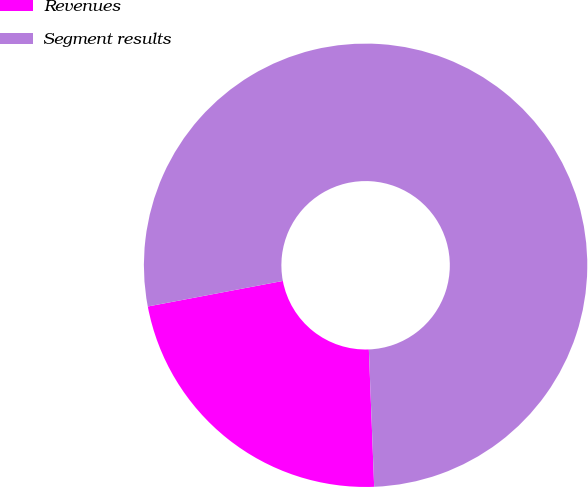Convert chart to OTSL. <chart><loc_0><loc_0><loc_500><loc_500><pie_chart><fcel>Revenues<fcel>Segment results<nl><fcel>22.64%<fcel>77.36%<nl></chart> 